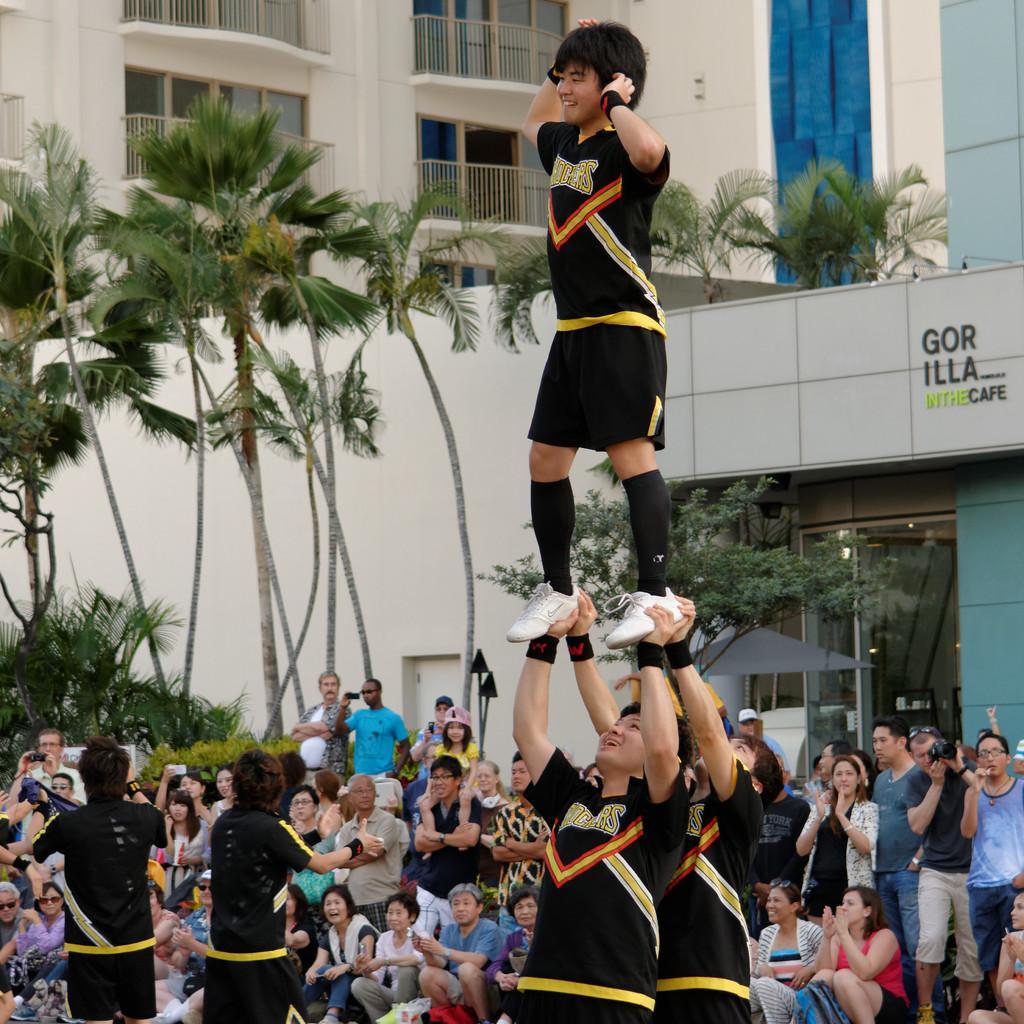How would you summarize this image in a sentence or two? In this picture I can see there are two men standing and there is a person standing on them, there are two people standing on the left, there are a few audience around them, there are plants, trees and buildings in the backdrop. 